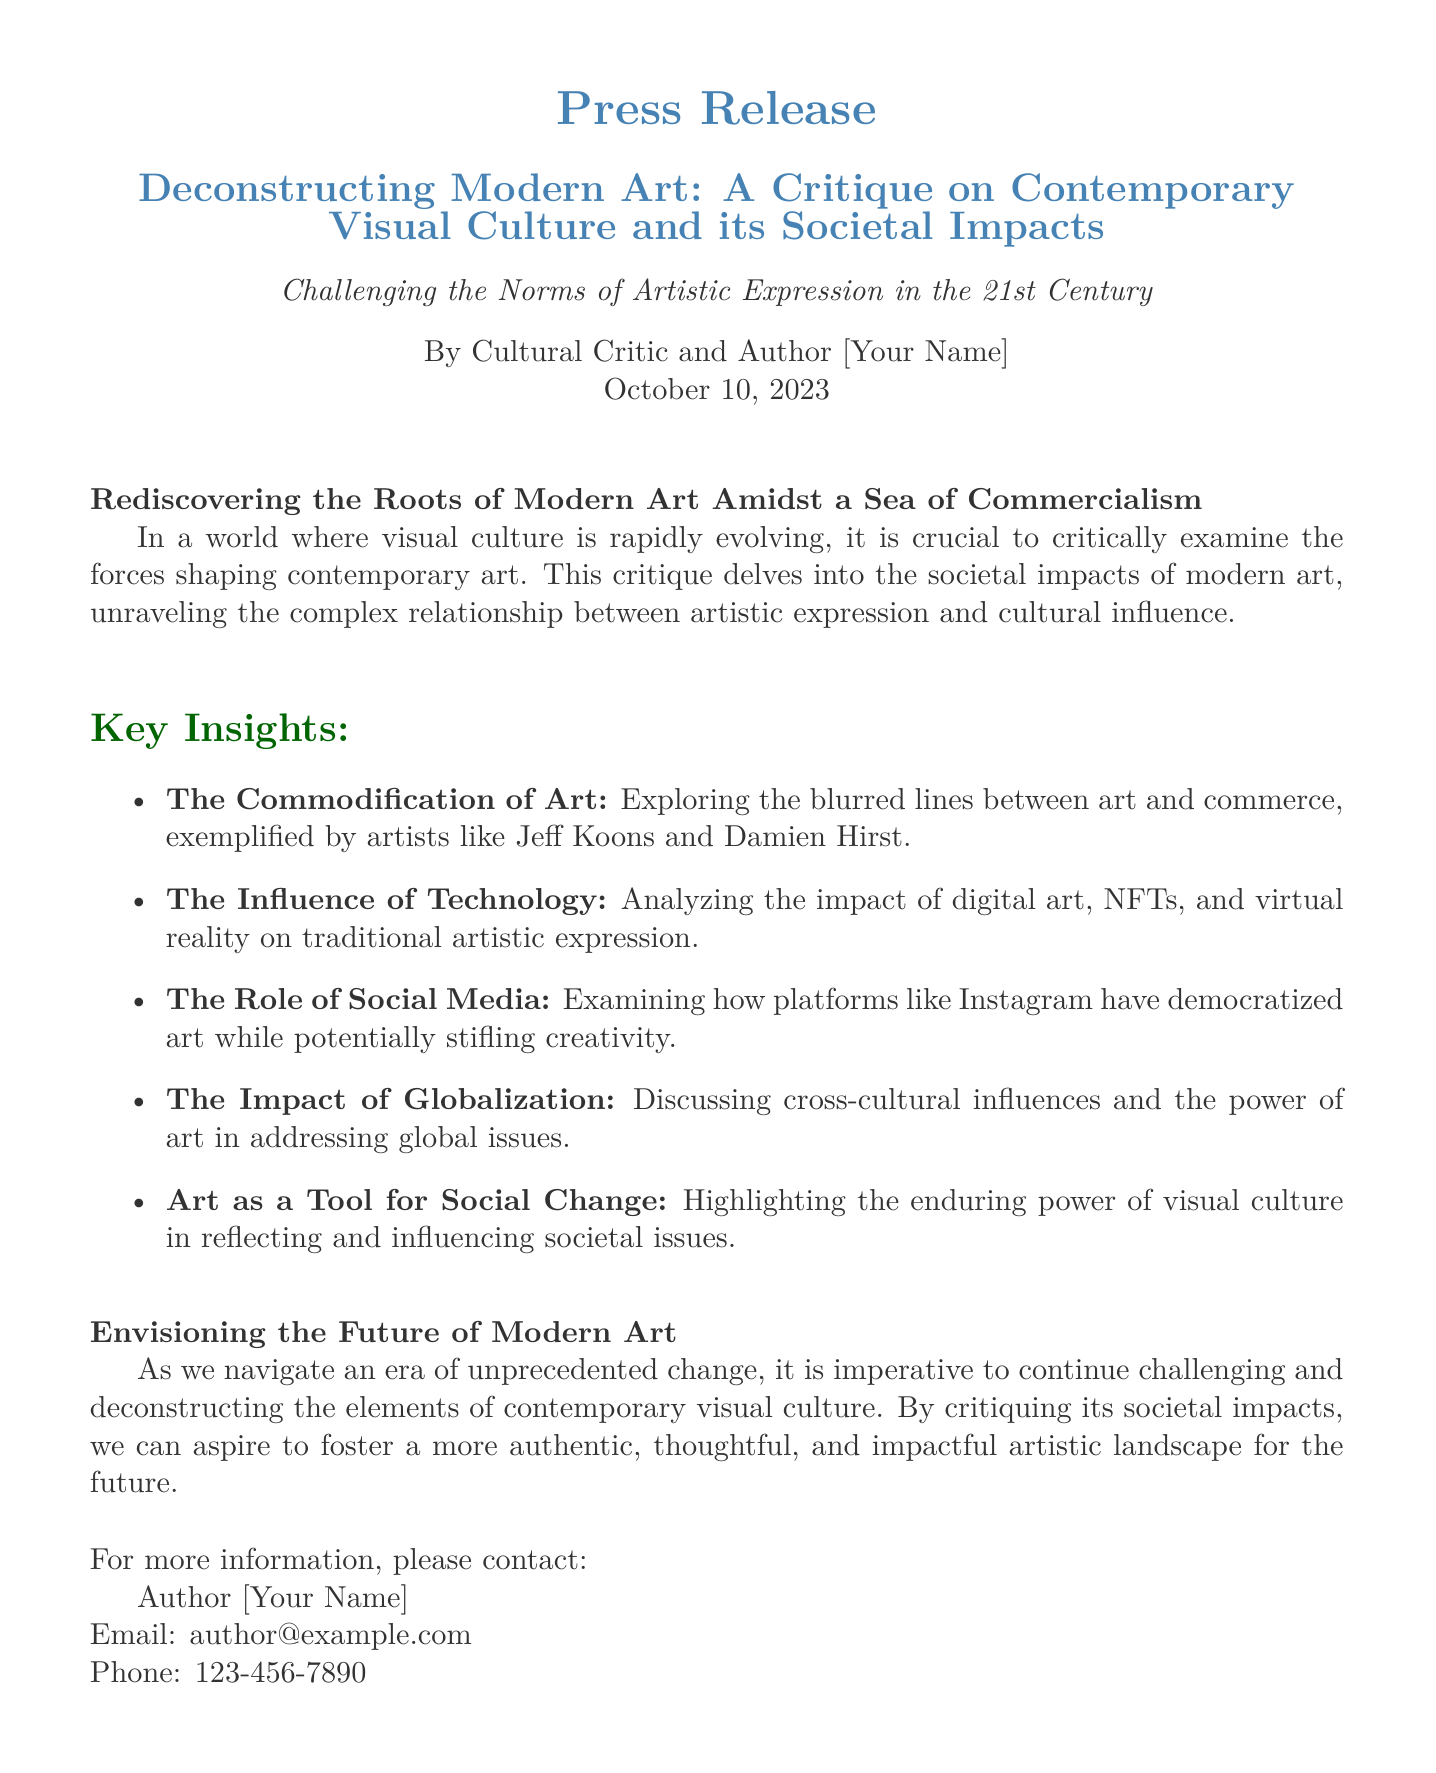What is the title of the press release? The title is prominently displayed in the document, highlighting the main topic of discussion.
Answer: Deconstructing Modern Art: A Critique on Contemporary Visual Culture and its Societal Impacts Who authored the press release? The author’s name is mentioned at the beginning, indicating the creator of the critique.
Answer: [Your Name] What date was the press release issued? The date appears directly under the author’s name, providing a specific timeframe for its relevance.
Answer: October 10, 2023 What are the key insights mentioned in the document? The key insights are presented in a list format, summarizing the main points of the critique.
Answer: The Commodification of Art, The Influence of Technology, The Role of Social Media, The Impact of Globalization, Art as a Tool for Social Change Which artist is cited in relation to the commodification of art? The document specifies examples of artists to illustrate the concept of commodification.
Answer: Jeff Koons Why is social media noted in the document? The reasoning behind its mention is to evaluate its dual role in promoting and potentially constraining artistic expression.
Answer: Examining how platforms like Instagram have democratized art while potentially stifling creativity What is the ultimate goal discussed in the press release? The final thoughts in the document outline aspirations for the future of artistic expression.
Answer: Foster a more authentic, thoughtful, and impactful artistic landscape for the future 